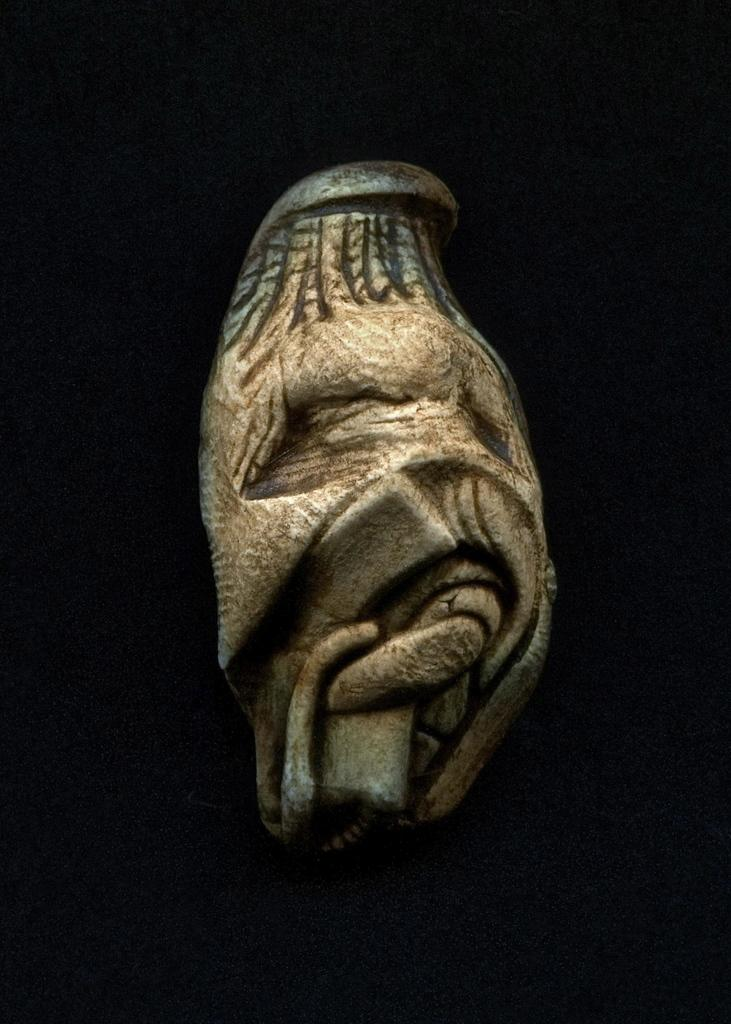What is the main subject of the image? There is a sculpture in the image. What can be observed about the background of the image? The background of the image is dark. Did the earthquake cause the crate to fall over in the image? There is no crate or any indication of an earthquake in the image; it only features a sculpture with a dark background. 